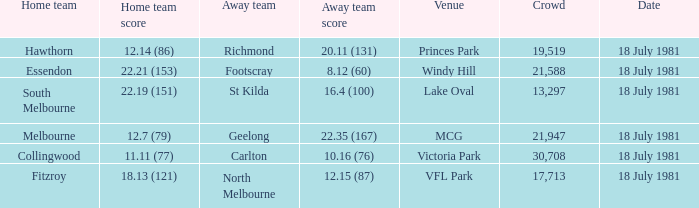When was the essendon home contest held? 18 July 1981. 